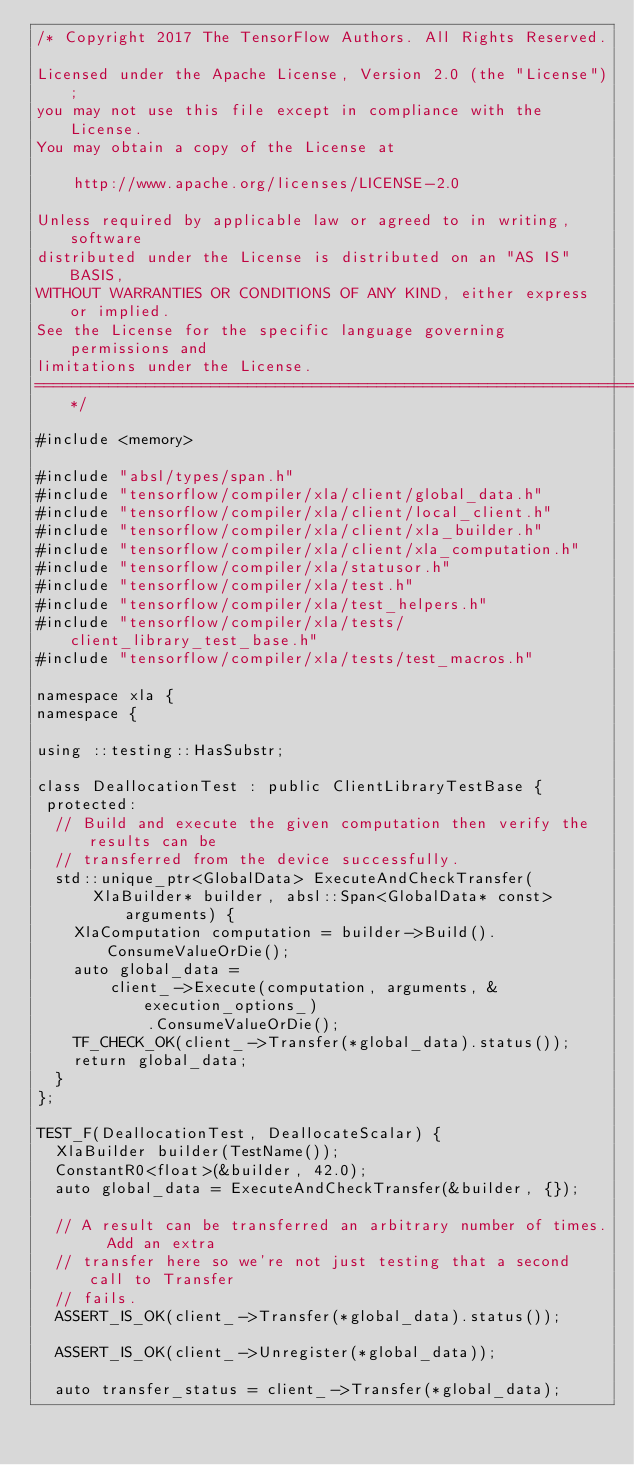<code> <loc_0><loc_0><loc_500><loc_500><_C++_>/* Copyright 2017 The TensorFlow Authors. All Rights Reserved.

Licensed under the Apache License, Version 2.0 (the "License");
you may not use this file except in compliance with the License.
You may obtain a copy of the License at

    http://www.apache.org/licenses/LICENSE-2.0

Unless required by applicable law or agreed to in writing, software
distributed under the License is distributed on an "AS IS" BASIS,
WITHOUT WARRANTIES OR CONDITIONS OF ANY KIND, either express or implied.
See the License for the specific language governing permissions and
limitations under the License.
==============================================================================*/

#include <memory>

#include "absl/types/span.h"
#include "tensorflow/compiler/xla/client/global_data.h"
#include "tensorflow/compiler/xla/client/local_client.h"
#include "tensorflow/compiler/xla/client/xla_builder.h"
#include "tensorflow/compiler/xla/client/xla_computation.h"
#include "tensorflow/compiler/xla/statusor.h"
#include "tensorflow/compiler/xla/test.h"
#include "tensorflow/compiler/xla/test_helpers.h"
#include "tensorflow/compiler/xla/tests/client_library_test_base.h"
#include "tensorflow/compiler/xla/tests/test_macros.h"

namespace xla {
namespace {

using ::testing::HasSubstr;

class DeallocationTest : public ClientLibraryTestBase {
 protected:
  // Build and execute the given computation then verify the results can be
  // transferred from the device successfully.
  std::unique_ptr<GlobalData> ExecuteAndCheckTransfer(
      XlaBuilder* builder, absl::Span<GlobalData* const> arguments) {
    XlaComputation computation = builder->Build().ConsumeValueOrDie();
    auto global_data =
        client_->Execute(computation, arguments, &execution_options_)
            .ConsumeValueOrDie();
    TF_CHECK_OK(client_->Transfer(*global_data).status());
    return global_data;
  }
};

TEST_F(DeallocationTest, DeallocateScalar) {
  XlaBuilder builder(TestName());
  ConstantR0<float>(&builder, 42.0);
  auto global_data = ExecuteAndCheckTransfer(&builder, {});

  // A result can be transferred an arbitrary number of times.  Add an extra
  // transfer here so we're not just testing that a second call to Transfer
  // fails.
  ASSERT_IS_OK(client_->Transfer(*global_data).status());

  ASSERT_IS_OK(client_->Unregister(*global_data));

  auto transfer_status = client_->Transfer(*global_data);</code> 